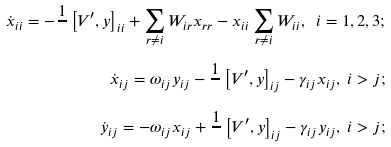Convert formula to latex. <formula><loc_0><loc_0><loc_500><loc_500>\dot { x } _ { i i } = - \frac { 1 } { } \left [ V ^ { \prime } , y \right ] _ { i i } + \sum _ { r \neq i } W _ { i r } x _ { r r } - x _ { i i } \sum _ { r \neq i } W _ { i i } , \text { } i = 1 , 2 , 3 ; \\ \dot { x } _ { i j } = \omega _ { i j } y _ { i j } - \frac { 1 } { } \left [ V ^ { \prime } , y \right ] _ { i j } - \gamma _ { i j } x _ { i j } , \text { } i > j ; \\ \dot { y } _ { i j } = - \omega _ { i j } x _ { i j } + \frac { 1 } { } \left [ V ^ { \prime } , y \right ] _ { i j } - \gamma _ { i j } y _ { i j } , \text { } i > j ;</formula> 